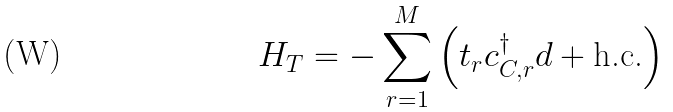Convert formula to latex. <formula><loc_0><loc_0><loc_500><loc_500>H _ { T } = - \sum _ { r = 1 } ^ { M } \left ( t _ { r } c _ { C , r } ^ { \dag } d + \text {h.c.} \right )</formula> 